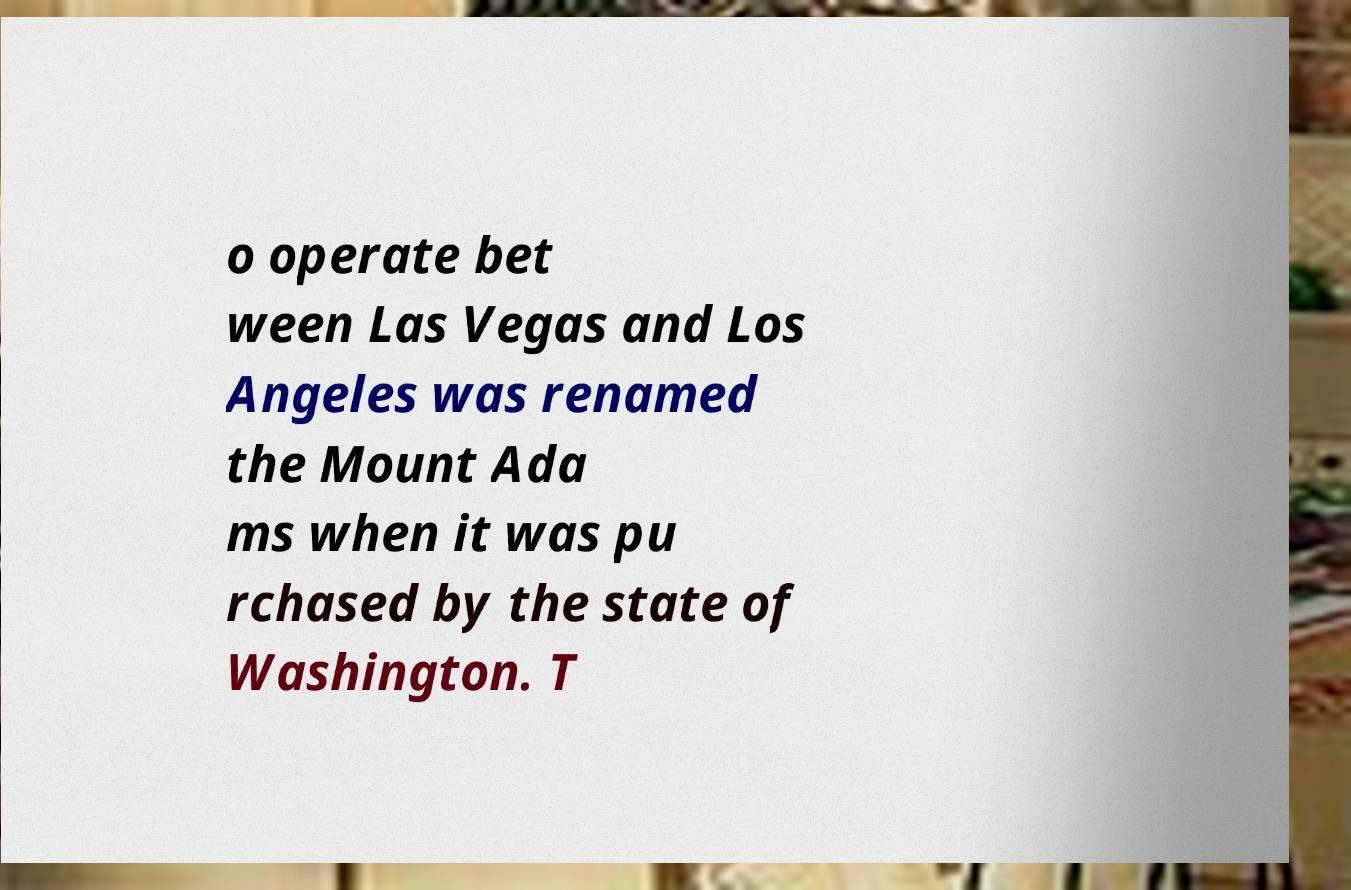Could you assist in decoding the text presented in this image and type it out clearly? o operate bet ween Las Vegas and Los Angeles was renamed the Mount Ada ms when it was pu rchased by the state of Washington. T 